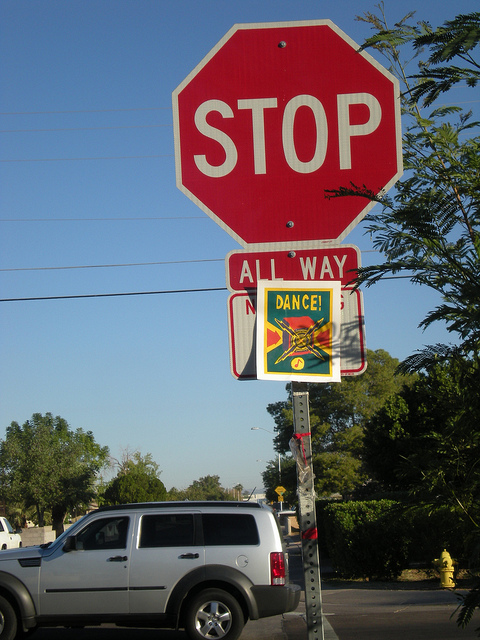Please transcribe the text information in this image. STOP ALL WAY DANCE! 